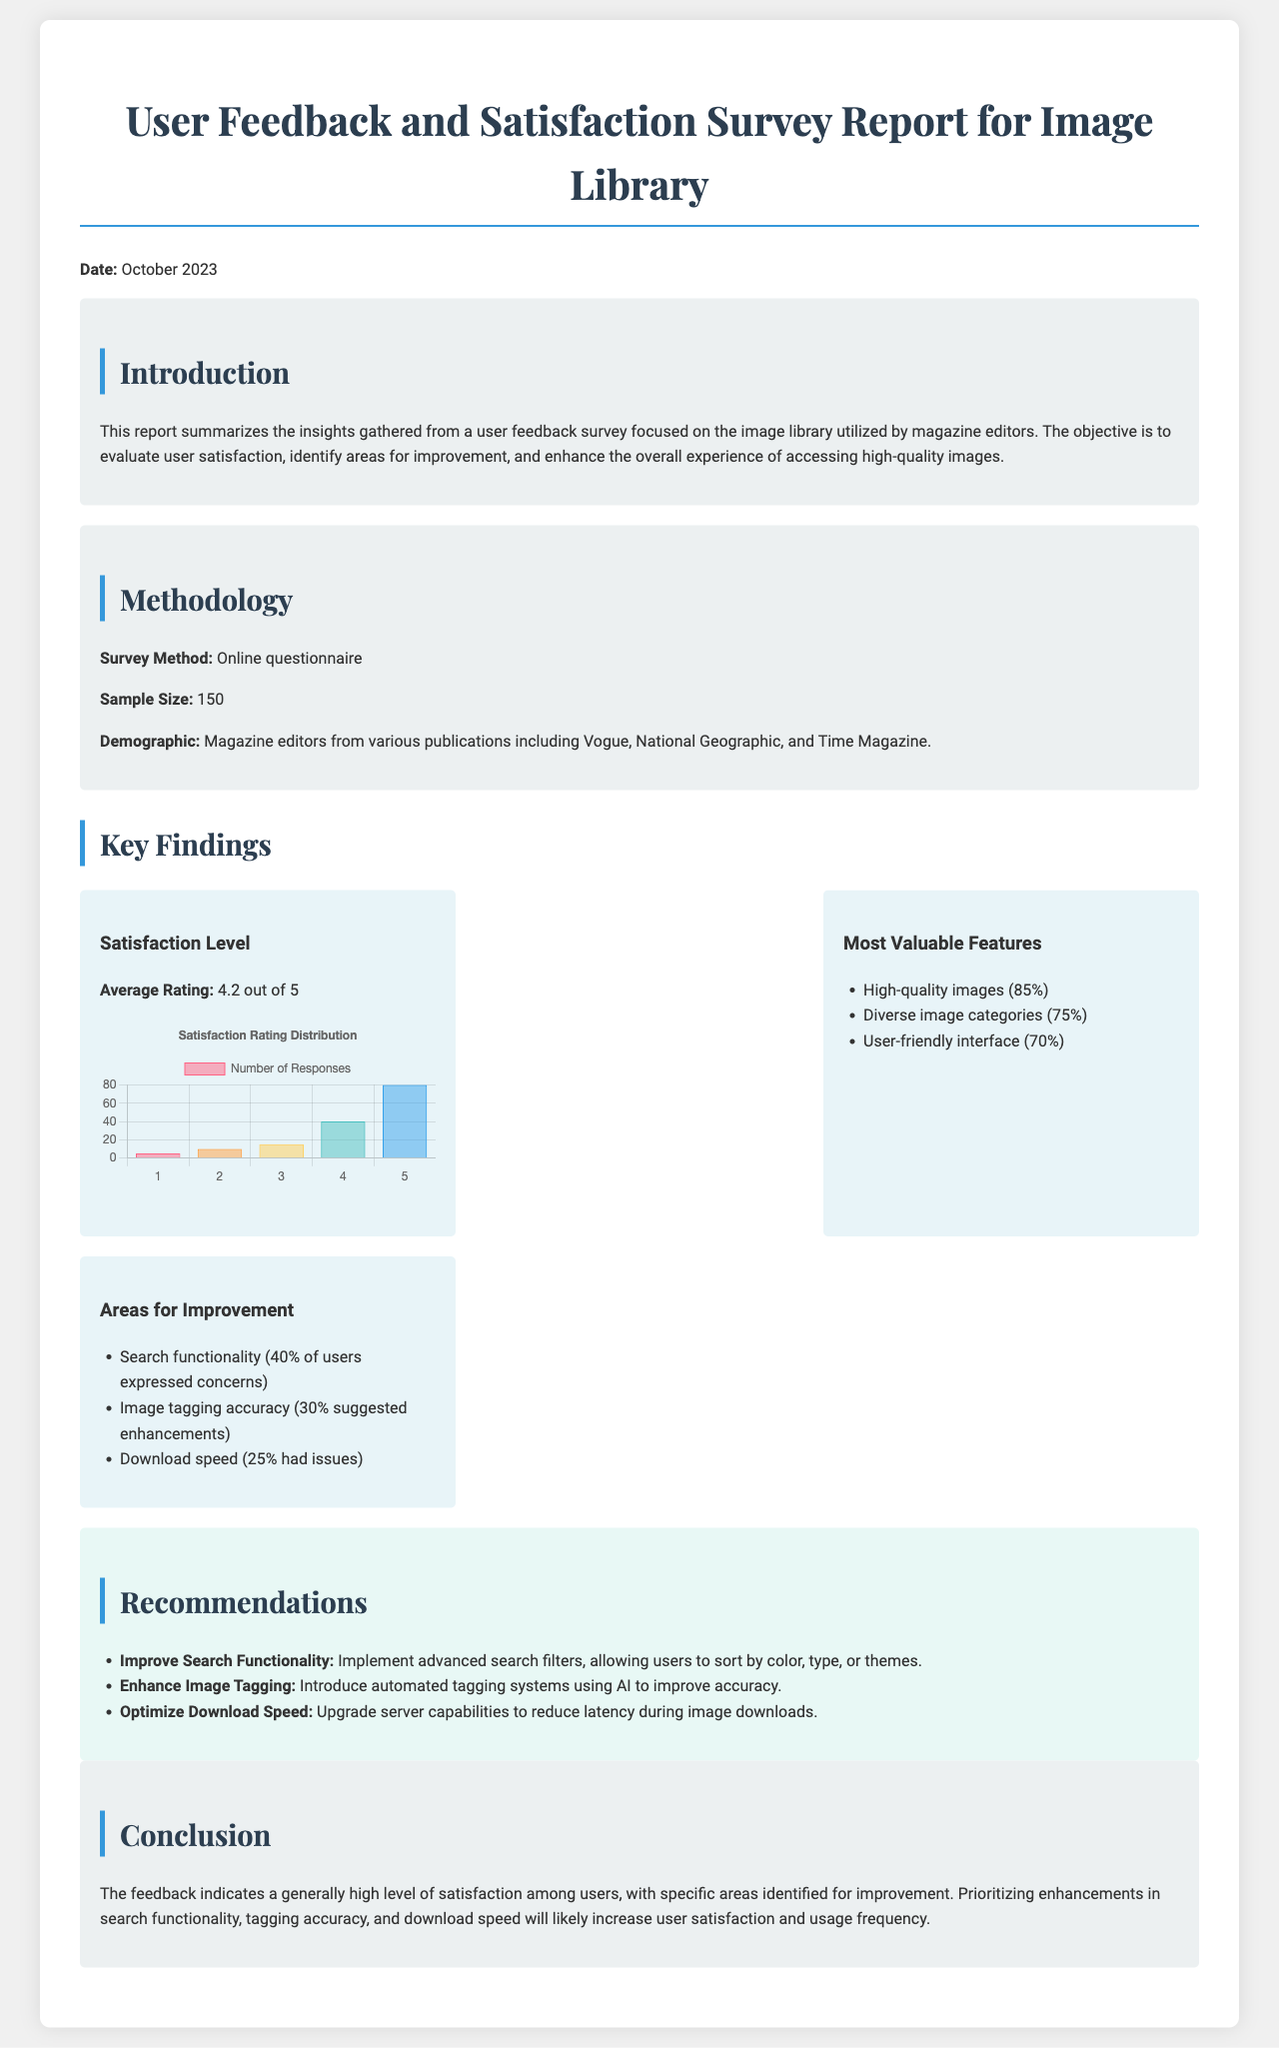What is the survey sample size? The sample size of the survey is explicitly stated in the methodology section of the document.
Answer: 150 What is the average satisfaction rating? The average rating is provided in the key findings section under satisfaction level.
Answer: 4.2 out of 5 What percentage of users valued high-quality images? The document lists the most valuable features along with their respective percentages.
Answer: 85% What area had the highest concern from users? The areas for improvement section mentions concerns expressed by users.
Answer: Search functionality What recommendations are given to enhance download speed? The recommendations section specifies actions meant to optimize download speed.
Answer: Upgrade server capabilities How many responses were received for a rating of 4? The detailed satisfaction chart shows the distribution of responses for each rating.
Answer: 40 What demographic participated in the survey? The document outlines the demographic details found in the methodology section.
Answer: Magazine editors from various publications What percentage of users expressed concerns about image tagging accuracy? The areas for improvement section specifies concerns expressed by users.
Answer: 30% What is the publication date of the report? The publication date is explicitly mentioned at the beginning of the document.
Answer: October 2023 